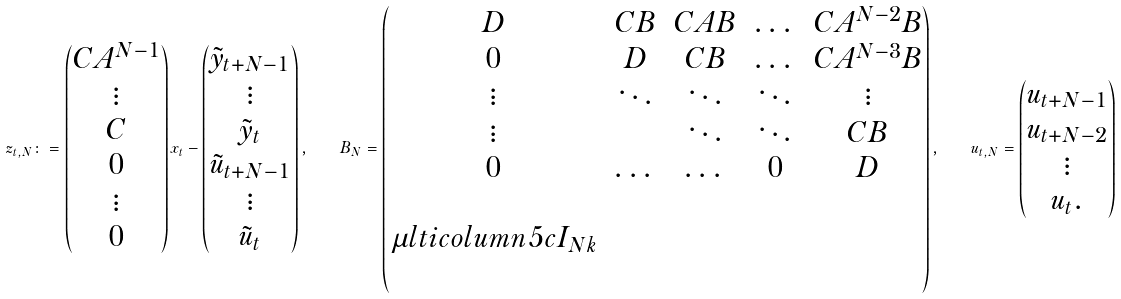Convert formula to latex. <formula><loc_0><loc_0><loc_500><loc_500>z _ { t , N } \colon = \begin{pmatrix} C A ^ { N - 1 } \\ \vdots \\ C \\ 0 \\ \vdots \\ 0 \\ \end{pmatrix} x _ { t } - \begin{pmatrix} \tilde { y } _ { t + N - 1 } \\ \vdots \\ \tilde { y } _ { t } \\ \tilde { u } _ { t + N - 1 } \\ \vdots \\ \tilde { u } _ { t } \end{pmatrix} , \quad B _ { N } = \begin{pmatrix} D & C B & C A B & \dots & C A ^ { N - 2 } B \\ 0 & D & C B & \dots & C A ^ { N - 3 } B \\ \vdots & \ddots & \ddots & \ddots & \vdots \\ \vdots & & \ddots & \ddots & C B \\ 0 & \dots & \dots & 0 & D \\ & & & & \\ \mu l t i c o l u m n { 5 } { c } { I _ { N k } } \\ & & & & \end{pmatrix} , \quad u _ { t , N } = \begin{pmatrix} u _ { t + N - 1 } \\ u _ { t + N - 2 } \\ \vdots \\ u _ { t } . \end{pmatrix}</formula> 